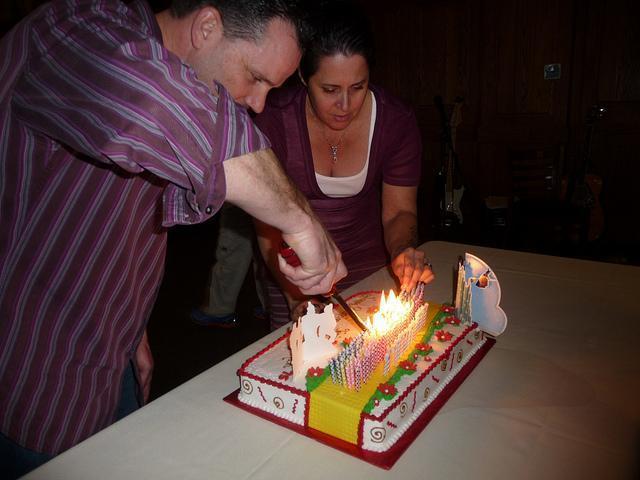How many different colored candles are there?
Give a very brief answer. 3. How many people are in the photo?
Give a very brief answer. 2. How many trains on the track?
Give a very brief answer. 0. 